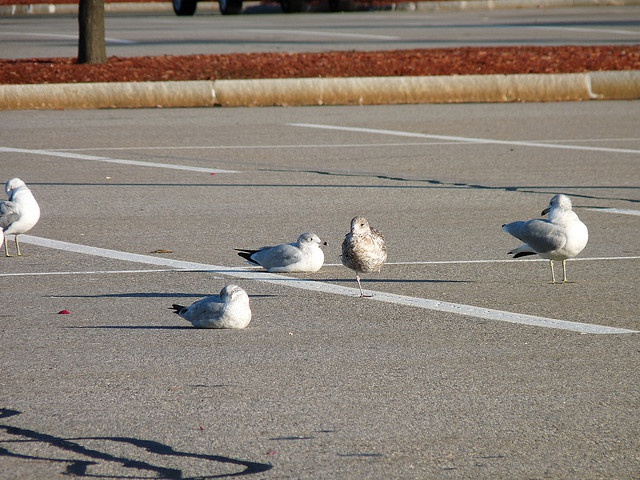Describe the objects in this image and their specific colors. I can see bird in maroon, white, gray, darkgray, and black tones, bird in maroon, white, darkgray, blue, and gray tones, bird in maroon, ivory, darkgray, gray, and black tones, bird in maroon, white, darkblue, navy, and gray tones, and bird in maroon, white, darkgray, gray, and beige tones in this image. 